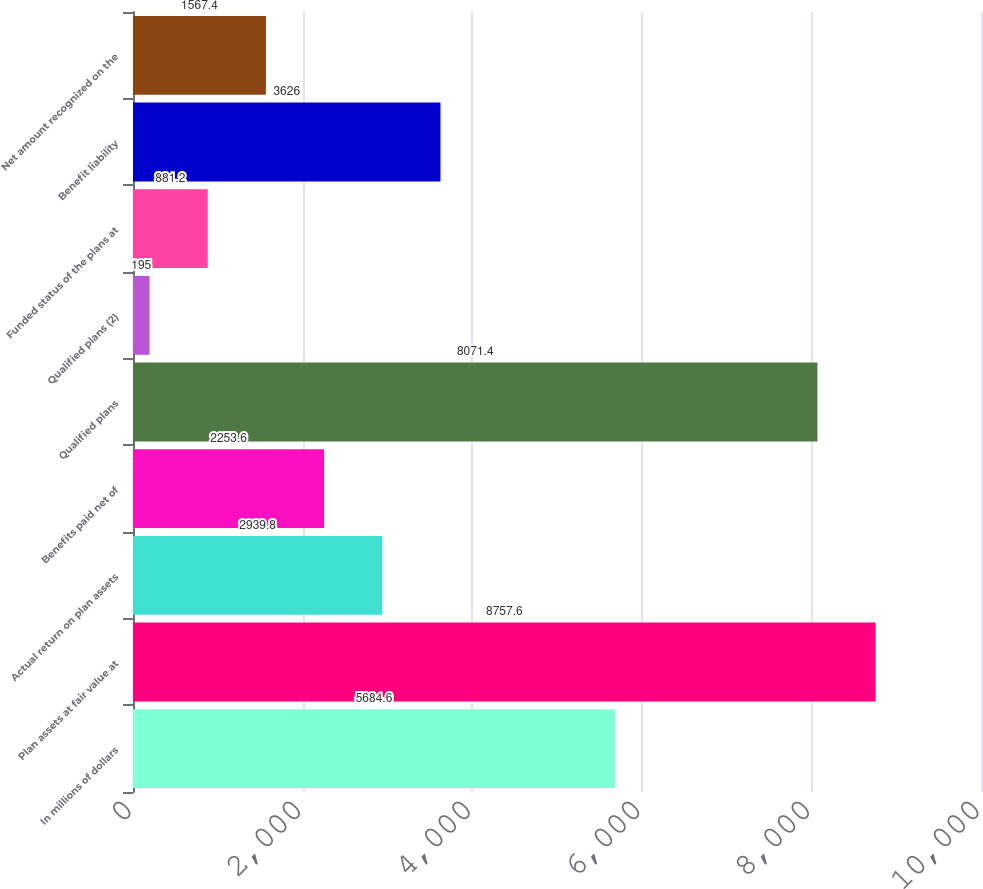Convert chart to OTSL. <chart><loc_0><loc_0><loc_500><loc_500><bar_chart><fcel>In millions of dollars<fcel>Plan assets at fair value at<fcel>Actual return on plan assets<fcel>Benefits paid net of<fcel>Qualified plans<fcel>Qualified plans (2)<fcel>Funded status of the plans at<fcel>Benefit liability<fcel>Net amount recognized on the<nl><fcel>5684.6<fcel>8757.6<fcel>2939.8<fcel>2253.6<fcel>8071.4<fcel>195<fcel>881.2<fcel>3626<fcel>1567.4<nl></chart> 